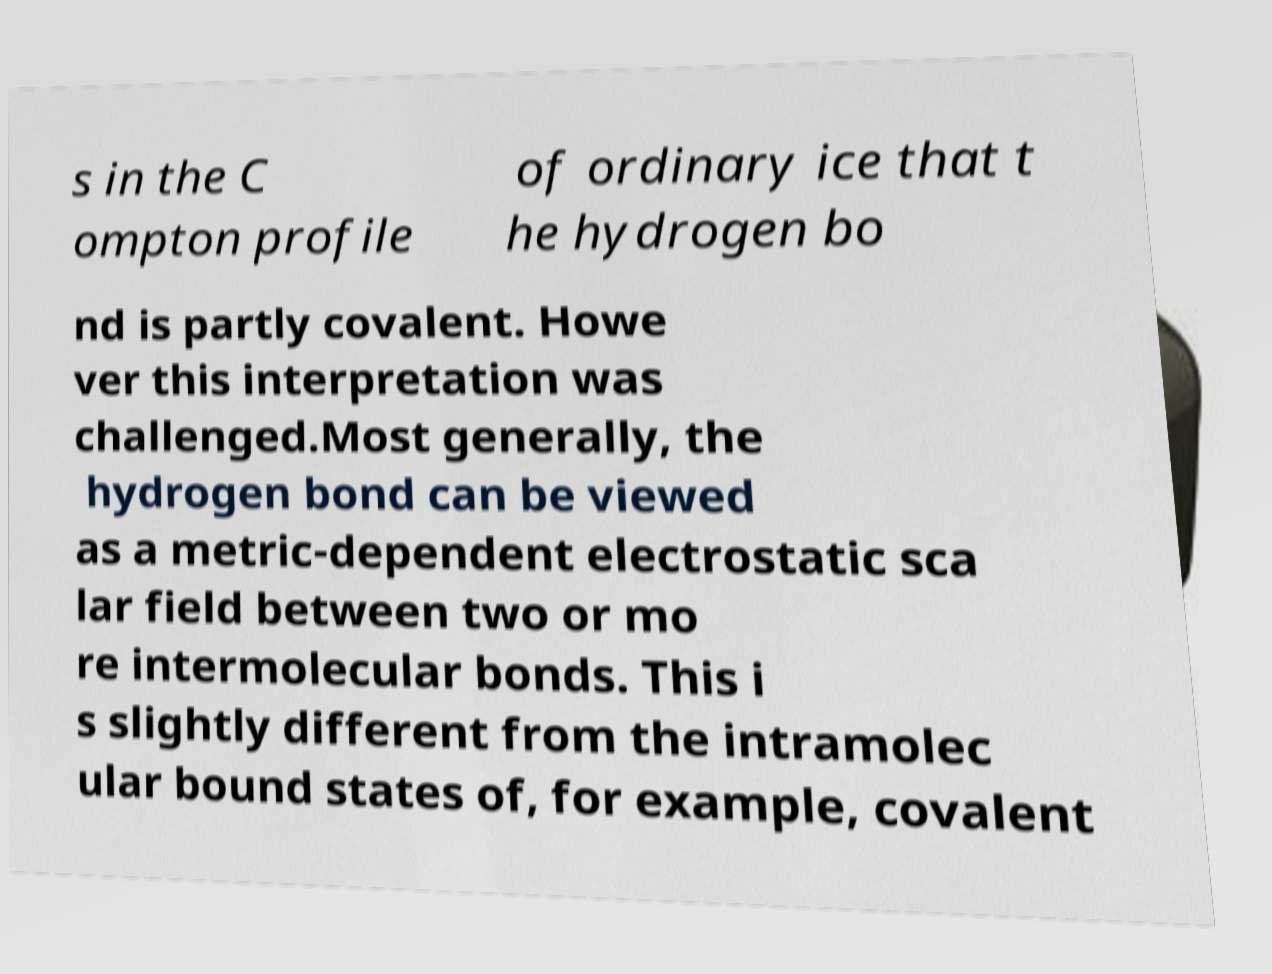What messages or text are displayed in this image? I need them in a readable, typed format. s in the C ompton profile of ordinary ice that t he hydrogen bo nd is partly covalent. Howe ver this interpretation was challenged.Most generally, the hydrogen bond can be viewed as a metric-dependent electrostatic sca lar field between two or mo re intermolecular bonds. This i s slightly different from the intramolec ular bound states of, for example, covalent 